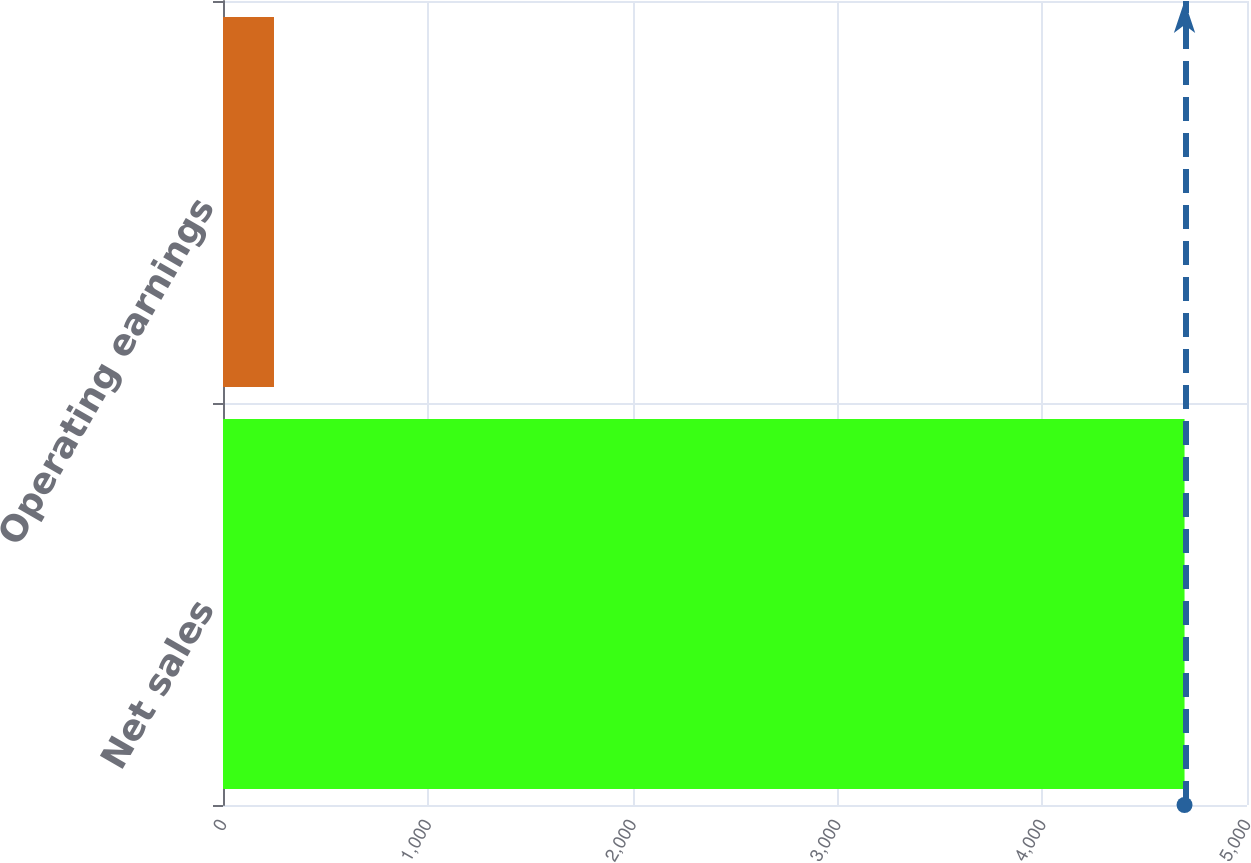Convert chart. <chart><loc_0><loc_0><loc_500><loc_500><bar_chart><fcel>Net sales<fcel>Operating earnings<nl><fcel>4695<fcel>249<nl></chart> 